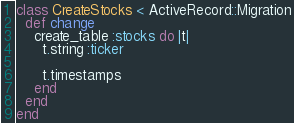<code> <loc_0><loc_0><loc_500><loc_500><_Ruby_>class CreateStocks < ActiveRecord::Migration
  def change
    create_table :stocks do |t|
      t.string :ticker

      t.timestamps
    end
  end
end
</code> 